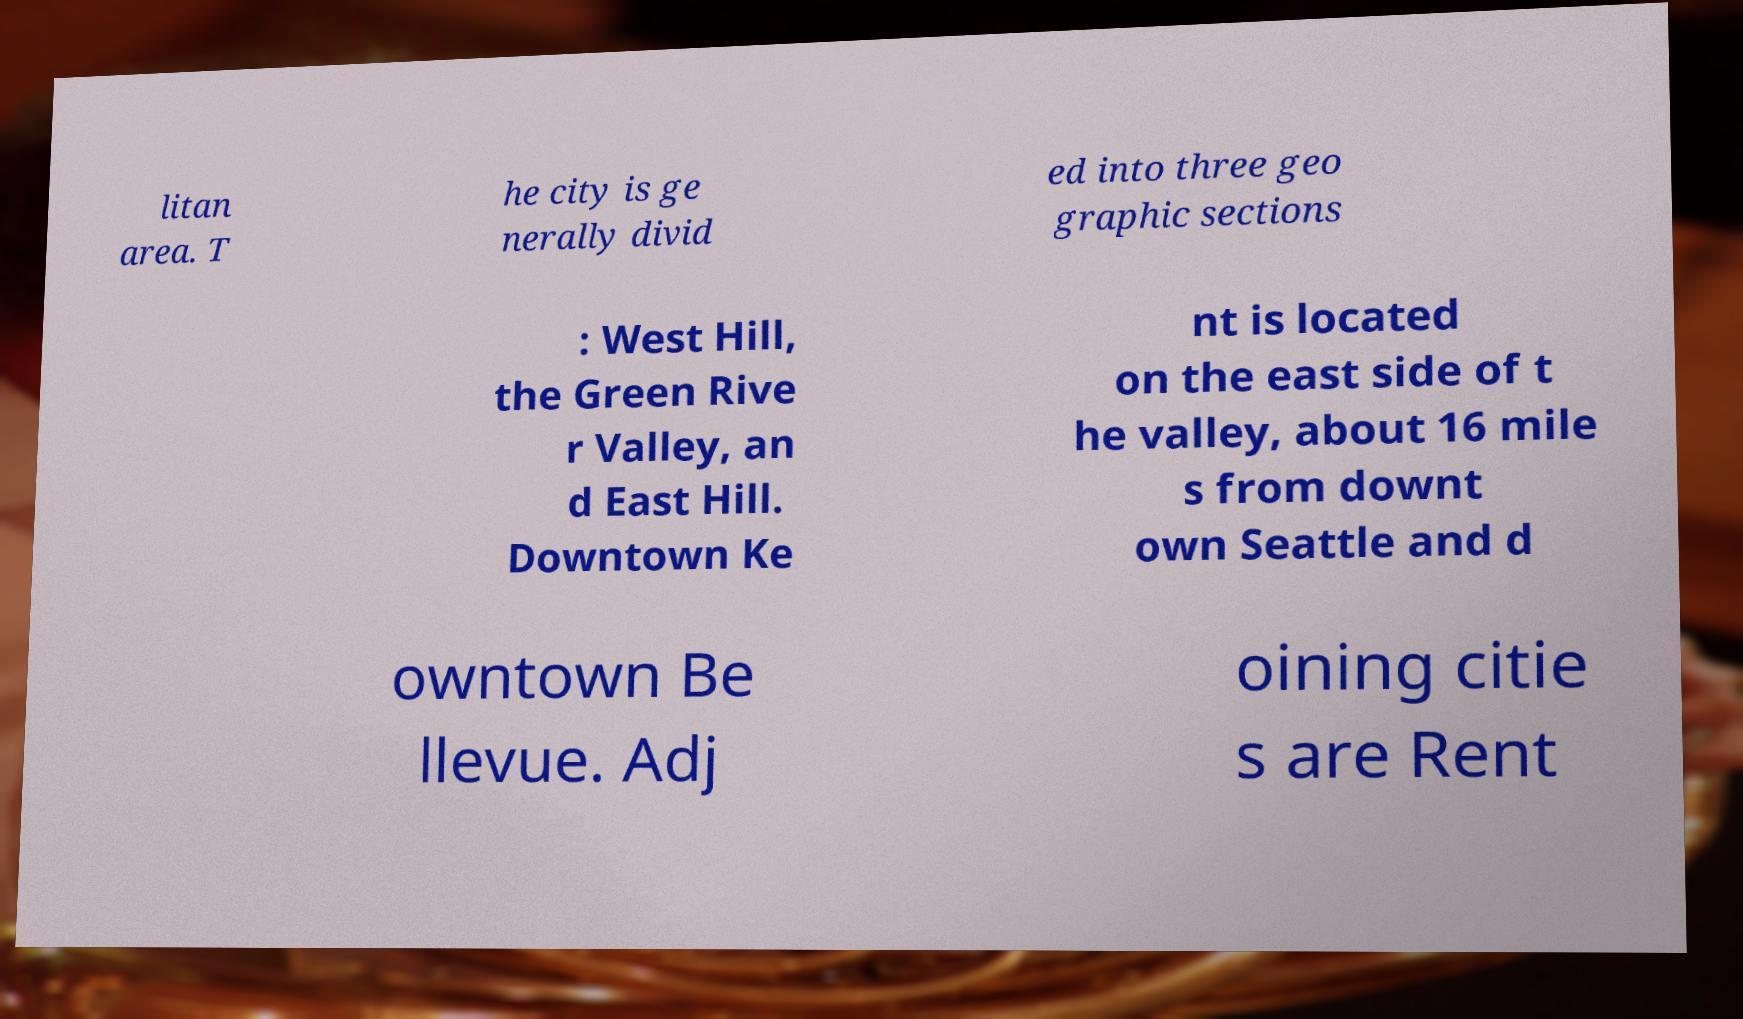Could you assist in decoding the text presented in this image and type it out clearly? litan area. T he city is ge nerally divid ed into three geo graphic sections : West Hill, the Green Rive r Valley, an d East Hill. Downtown Ke nt is located on the east side of t he valley, about 16 mile s from downt own Seattle and d owntown Be llevue. Adj oining citie s are Rent 